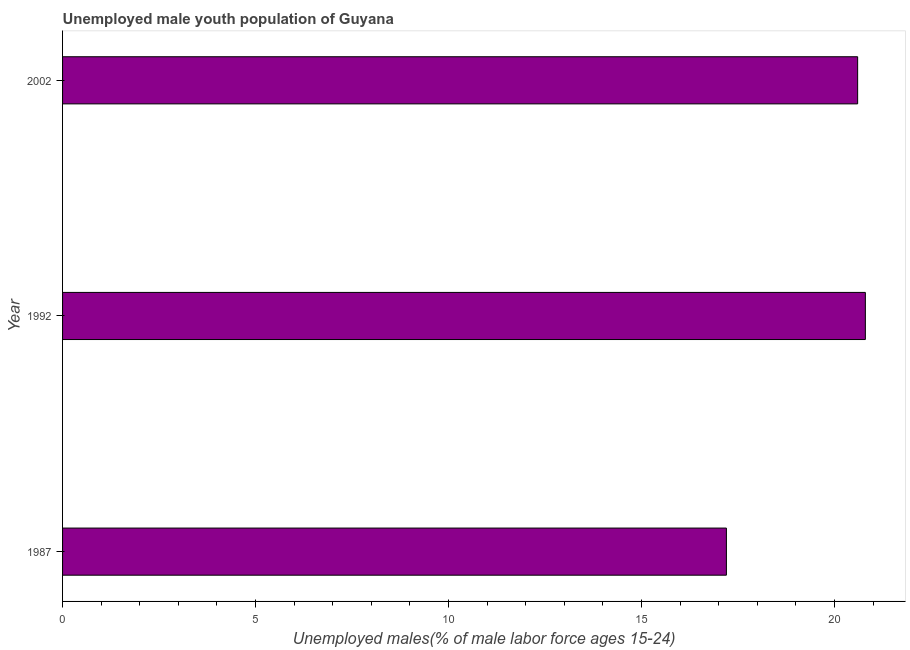Does the graph contain grids?
Give a very brief answer. No. What is the title of the graph?
Provide a short and direct response. Unemployed male youth population of Guyana. What is the label or title of the X-axis?
Keep it short and to the point. Unemployed males(% of male labor force ages 15-24). What is the unemployed male youth in 1987?
Provide a succinct answer. 17.2. Across all years, what is the maximum unemployed male youth?
Keep it short and to the point. 20.8. Across all years, what is the minimum unemployed male youth?
Your answer should be very brief. 17.2. In which year was the unemployed male youth maximum?
Your response must be concise. 1992. What is the sum of the unemployed male youth?
Offer a terse response. 58.6. What is the average unemployed male youth per year?
Offer a very short reply. 19.53. What is the median unemployed male youth?
Your answer should be very brief. 20.6. In how many years, is the unemployed male youth greater than 16 %?
Keep it short and to the point. 3. Do a majority of the years between 2002 and 1987 (inclusive) have unemployed male youth greater than 16 %?
Your answer should be very brief. Yes. What is the ratio of the unemployed male youth in 1987 to that in 2002?
Offer a very short reply. 0.83. Is the unemployed male youth in 1987 less than that in 2002?
Keep it short and to the point. Yes. Is the difference between the unemployed male youth in 1987 and 2002 greater than the difference between any two years?
Offer a terse response. No. What is the difference between the highest and the second highest unemployed male youth?
Make the answer very short. 0.2. What is the difference between the highest and the lowest unemployed male youth?
Provide a short and direct response. 3.6. How many bars are there?
Offer a terse response. 3. How many years are there in the graph?
Give a very brief answer. 3. What is the difference between two consecutive major ticks on the X-axis?
Provide a short and direct response. 5. What is the Unemployed males(% of male labor force ages 15-24) in 1987?
Provide a succinct answer. 17.2. What is the Unemployed males(% of male labor force ages 15-24) of 1992?
Your answer should be very brief. 20.8. What is the Unemployed males(% of male labor force ages 15-24) in 2002?
Offer a very short reply. 20.6. What is the difference between the Unemployed males(% of male labor force ages 15-24) in 1987 and 1992?
Your answer should be very brief. -3.6. What is the ratio of the Unemployed males(% of male labor force ages 15-24) in 1987 to that in 1992?
Offer a very short reply. 0.83. What is the ratio of the Unemployed males(% of male labor force ages 15-24) in 1987 to that in 2002?
Make the answer very short. 0.83. 